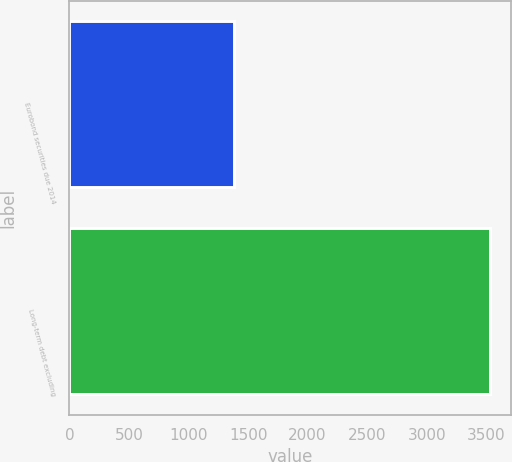Convert chart to OTSL. <chart><loc_0><loc_0><loc_500><loc_500><bar_chart><fcel>Eurobond securities due 2014<fcel>Long-term debt excluding<nl><fcel>1383<fcel>3533<nl></chart> 